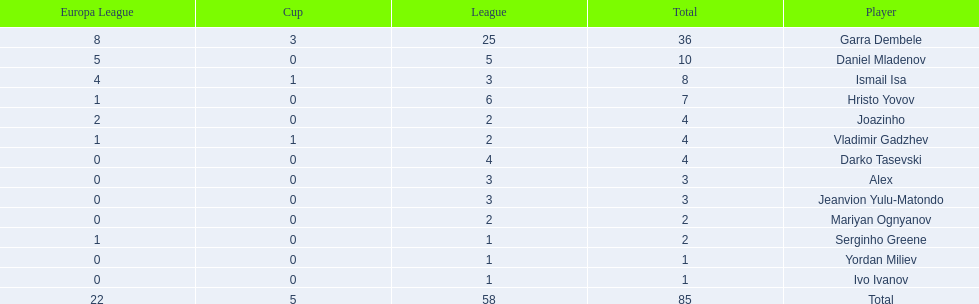Could you help me parse every detail presented in this table? {'header': ['Europa League', 'Cup', 'League', 'Total', 'Player'], 'rows': [['8', '3', '25', '36', 'Garra Dembele'], ['5', '0', '5', '10', 'Daniel Mladenov'], ['4', '1', '3', '8', 'Ismail Isa'], ['1', '0', '6', '7', 'Hristo Yovov'], ['2', '0', '2', '4', 'Joazinho'], ['1', '1', '2', '4', 'Vladimir Gadzhev'], ['0', '0', '4', '4', 'Darko Tasevski'], ['0', '0', '3', '3', 'Alex'], ['0', '0', '3', '3', 'Jeanvion Yulu-Matondo'], ['0', '0', '2', '2', 'Mariyan Ognyanov'], ['1', '0', '1', '2', 'Serginho Greene'], ['0', '0', '1', '1', 'Yordan Miliev'], ['0', '0', '1', '1', 'Ivo Ivanov'], ['22', '5', '58', '85', 'Total']]} Which is the only player from germany? Jeanvion Yulu-Matondo. 